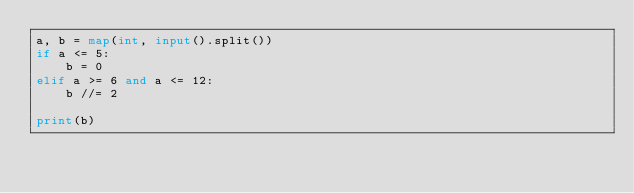<code> <loc_0><loc_0><loc_500><loc_500><_Python_>a, b = map(int, input().split())
if a <= 5:
    b = 0
elif a >= 6 and a <= 12:
    b //= 2

print(b)</code> 